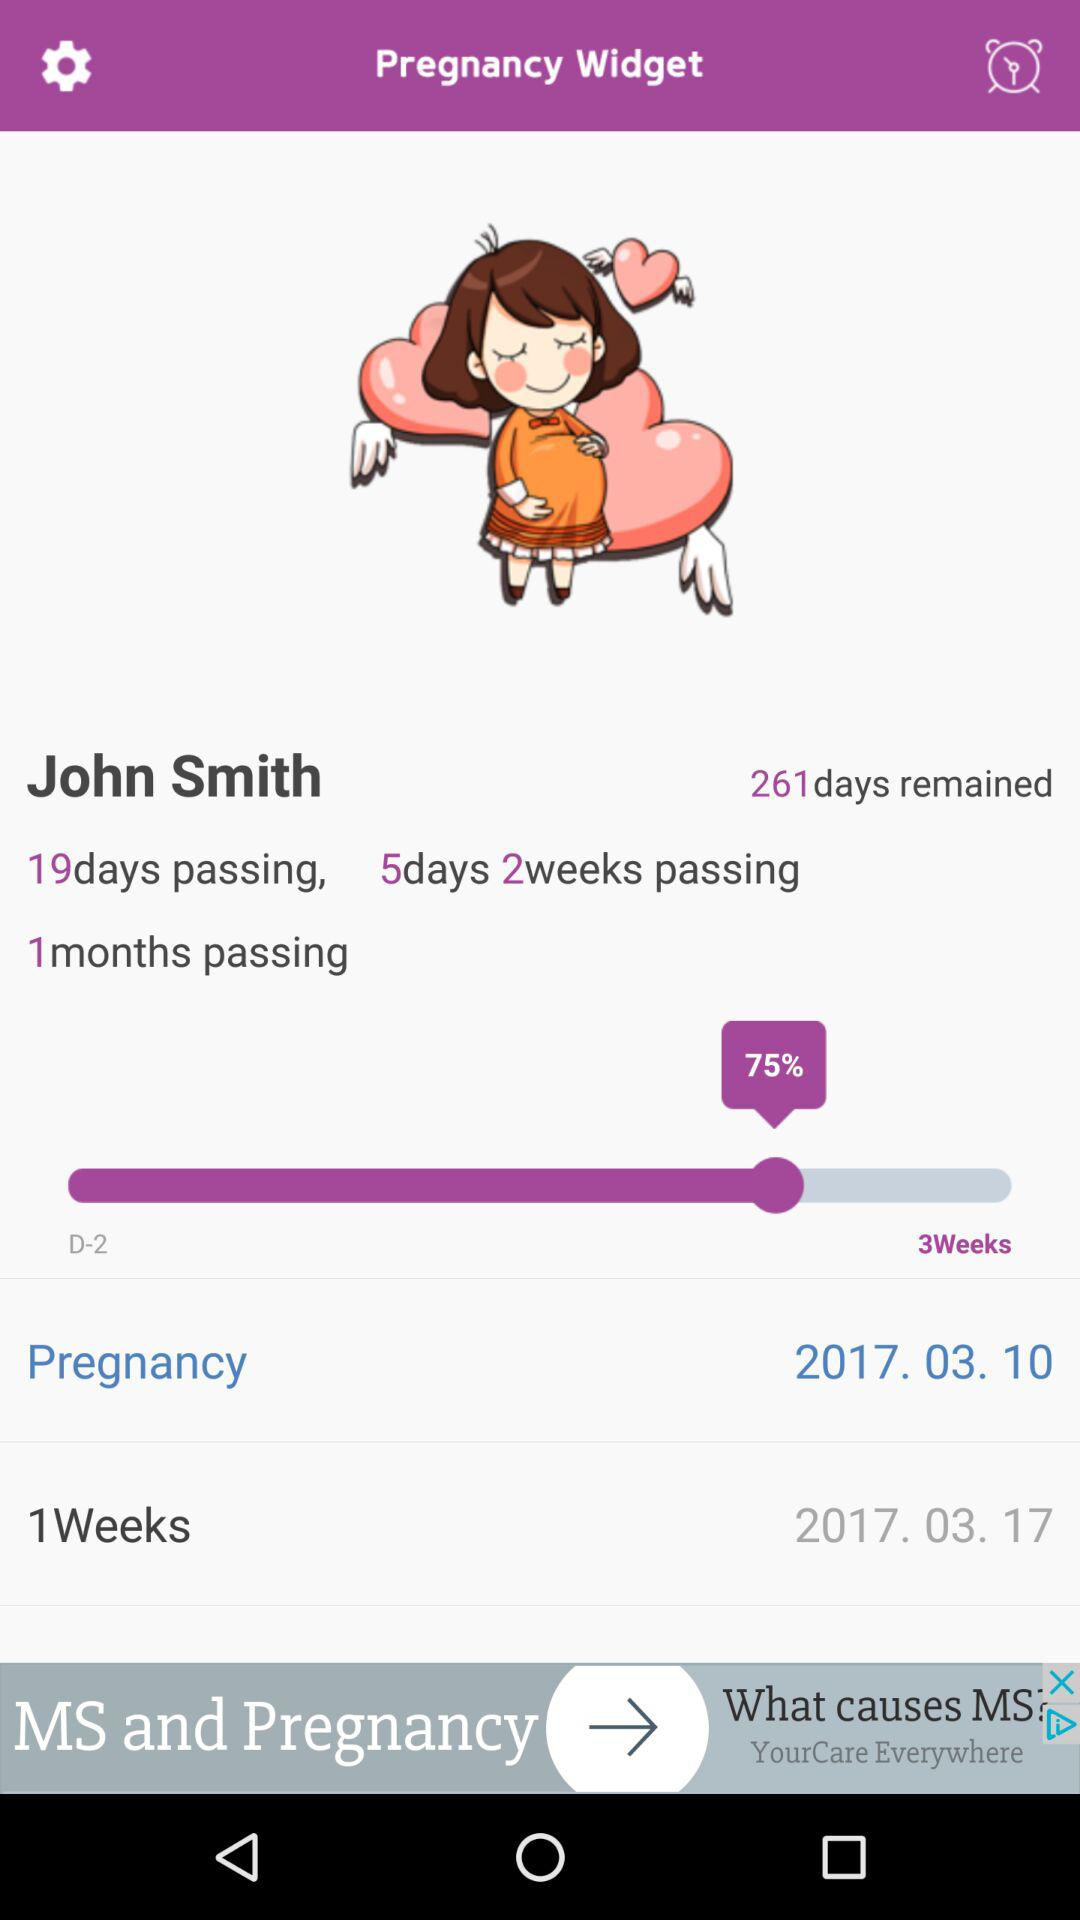What is the name? The name is John Smith. 